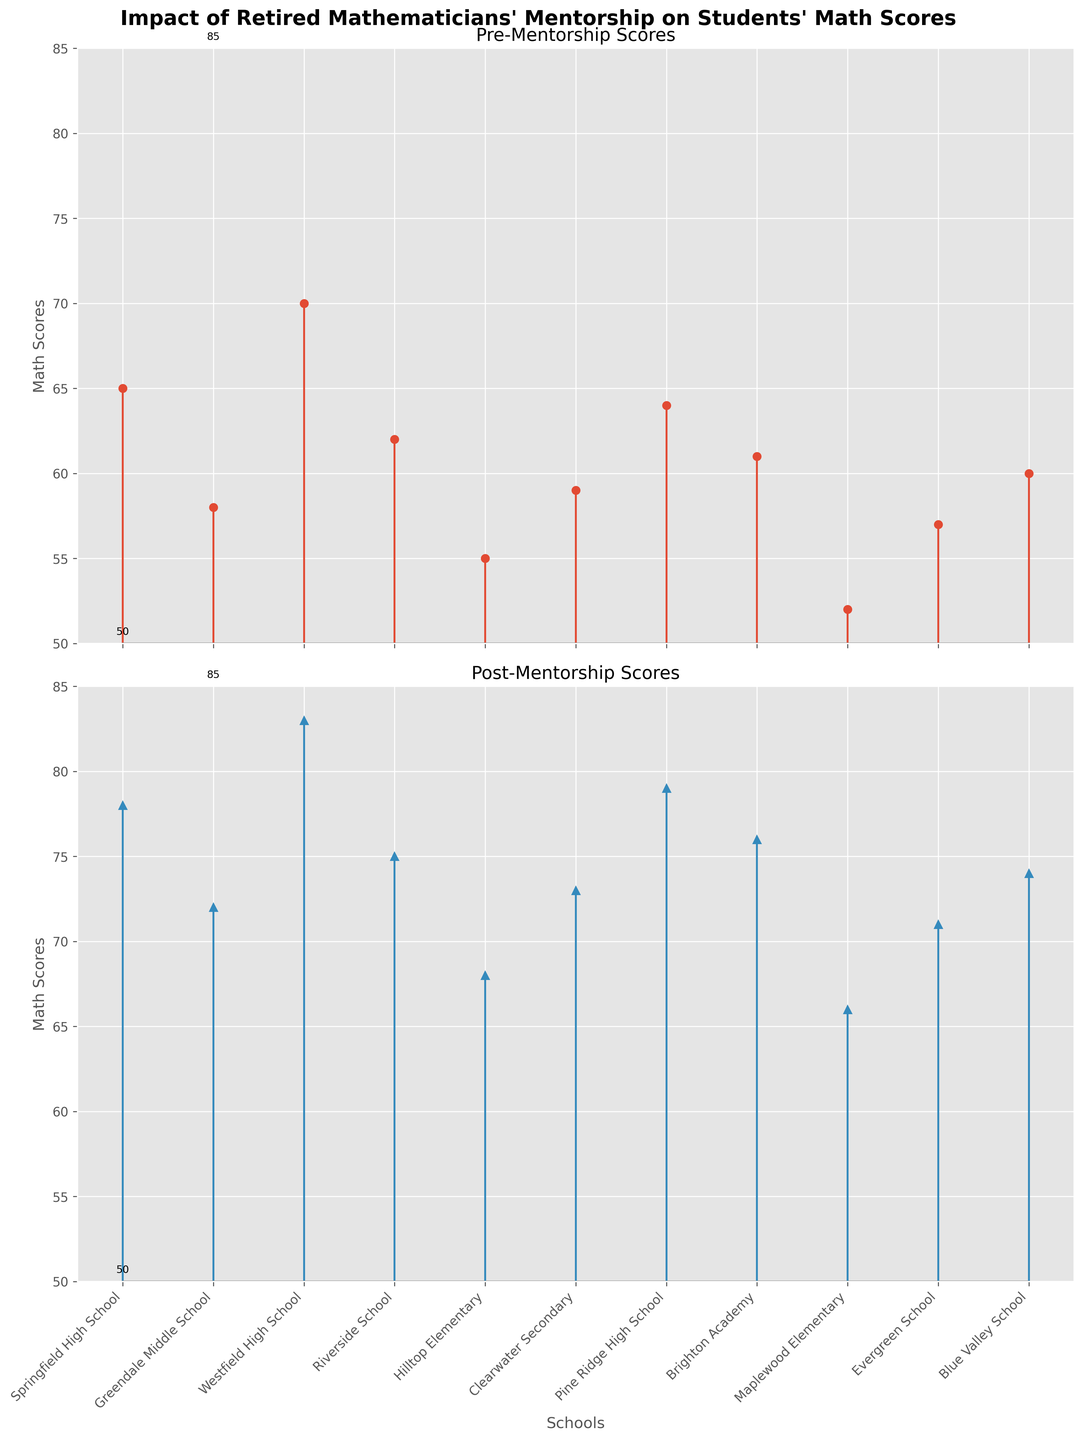What is the title of the figure? The title of the figure is shown at the top and reads "Impact of Retired Mathematicians' Mentorship on Students' Math Scores".
Answer: Impact of Retired Mathematicians' Mentorship on Students' Math Scores How many schools are depicted in the figure? There are labels along the x-axis in the figure for each school. By counting these labels, we can see that there are 11 schools shown.
Answer: 11 Which school had the highest pre-mentorship score? Look at the first subplot titled "Pre-Mentorship Scores" and identify the highest point on the y-axis. The corresponding x-axis label is the school with the highest pre-mentorship score. The highest point is at Westfield High School.
Answer: Westfield High School What is the average post-mentorship score across all schools? Add up all post-mentorship scores (78 + 72 + 83 + 75 + 68 + 73 + 79 + 76 + 66 + 71 + 74) and then divide by the number of scores (11). The calculation is (78 + 72 + 83 + 75 + 68 + 73 + 79 + 76 + 66 + 71 + 74) / 11.
Answer: 73.4 How much did the math score improve for Clearwater Secondary? Locate the scores for Clearwater Secondary on both subplots. Subtract the pre-mentorship score (59) from the post-mentorship score (73). The calculation is 73 - 59.
Answer: 14 Which school saw the least improvement in math scores? To find the least improvement, calculate the difference between pre- and post-mentorship scores for each school, then identify the smallest difference. The smallest difference is 11 at Brighton Academy.
Answer: Brighton Academy Are there any schools where the post-mentorship score did not exceed 70? Check the scores on the post-mentorship scores subplot and see if any of them are 70 or below. All post-mentorship scores are above 70, so no schools fall in this category.
Answer: No Which two schools had an equal increase in math scores? Calculate the difference between pre- and post-mentorship scores for each school, then look for matching differences. Clearwater Secondary and Pine Ridge High School both improved by 14 points.
Answer: Clearwater Secondary and Pine Ridge High School What was the math score at Maplewood Elementary before mentorship? Find Maplewood Elementary on the first subplot titled "Pre-Mentorship Scores". The pre-mentorship score for Maplewood Elementary is 52.
Answer: 52 How many schools achieved a post-mentorship score above 75? Count the number of points that exceed 75 on the second subplot titled "Post-Mentorship Scores". There are 6 schools that have scores above 75.
Answer: 6 